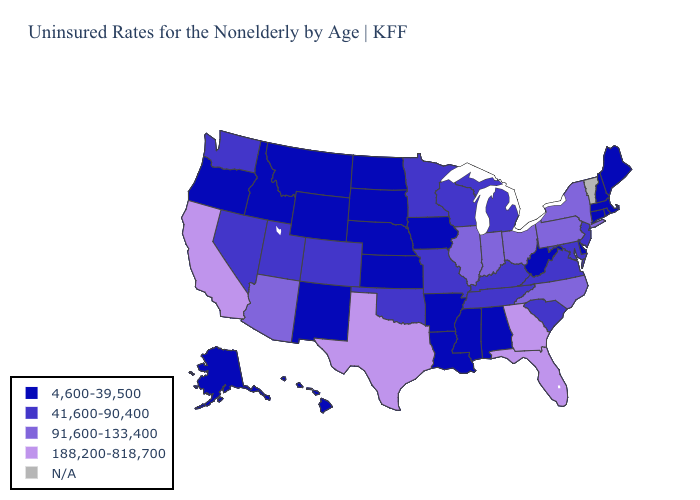What is the value of Mississippi?
Concise answer only. 4,600-39,500. Name the states that have a value in the range 41,600-90,400?
Concise answer only. Colorado, Kentucky, Maryland, Michigan, Minnesota, Missouri, Nevada, New Jersey, Oklahoma, South Carolina, Tennessee, Utah, Virginia, Washington, Wisconsin. Does Texas have the highest value in the USA?
Be succinct. Yes. Does Alabama have the highest value in the USA?
Quick response, please. No. What is the value of Connecticut?
Quick response, please. 4,600-39,500. Name the states that have a value in the range 91,600-133,400?
Answer briefly. Arizona, Illinois, Indiana, New York, North Carolina, Ohio, Pennsylvania. What is the value of Georgia?
Write a very short answer. 188,200-818,700. Among the states that border Texas , does Oklahoma have the highest value?
Concise answer only. Yes. What is the lowest value in the USA?
Short answer required. 4,600-39,500. Does Indiana have the highest value in the MidWest?
Concise answer only. Yes. Does Oregon have the lowest value in the USA?
Short answer required. Yes. Does California have the highest value in the USA?
Short answer required. Yes. What is the value of Illinois?
Write a very short answer. 91,600-133,400. Which states have the lowest value in the MidWest?
Be succinct. Iowa, Kansas, Nebraska, North Dakota, South Dakota. Among the states that border Kansas , does Nebraska have the lowest value?
Quick response, please. Yes. 